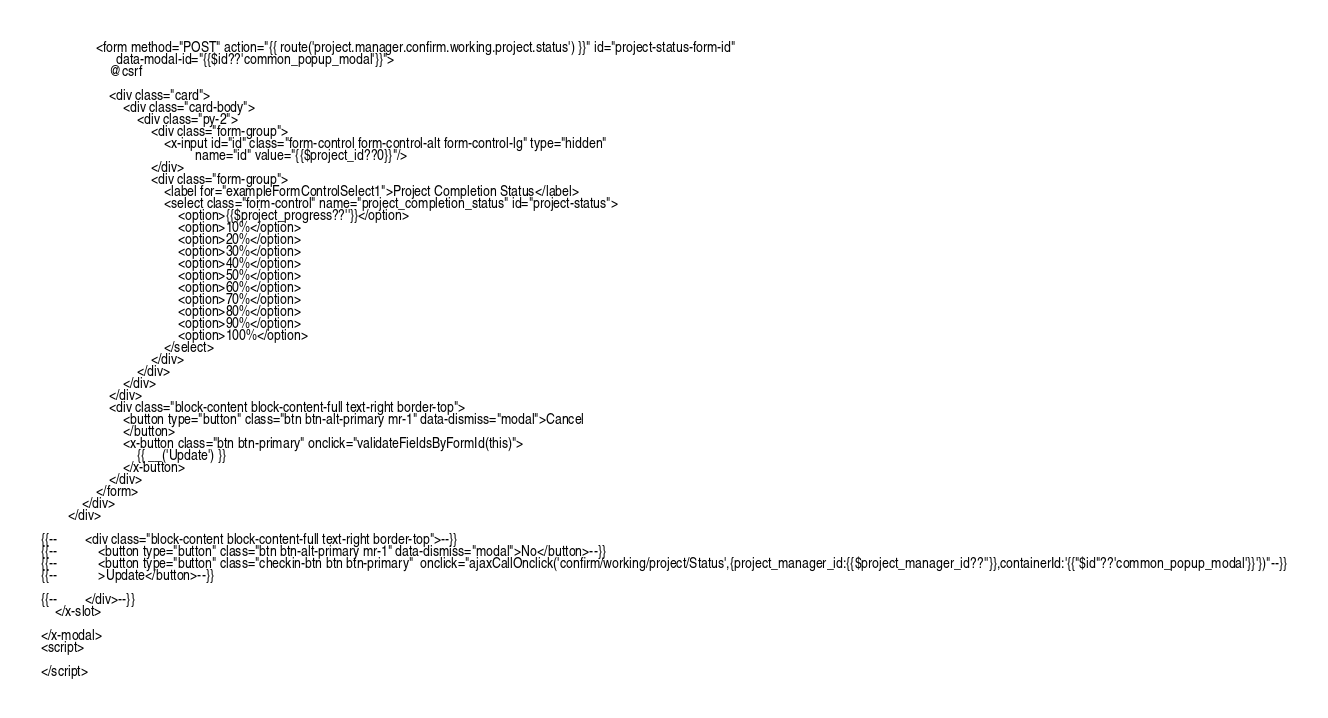Convert code to text. <code><loc_0><loc_0><loc_500><loc_500><_PHP_>                <form method="POST" action="{{ route('project.manager.confirm.working.project.status') }}" id="project-status-form-id"
                      data-modal-id="{{$id??'common_popup_modal'}}">
                    @csrf

                    <div class="card">
                        <div class="card-body">
                            <div class="py-2">
                                <div class="form-group">
                                    <x-input id="id" class="form-control form-control-alt form-control-lg" type="hidden"
                                             name="id" value="{{$project_id??0}}"/>
                                </div>
                                <div class="form-group">
                                    <label for="exampleFormControlSelect1">Project Completion Status</label>
                                    <select class="form-control" name="project_completion_status" id="project-status">
                                        <option>{{$project_progress??''}}</option>
                                        <option>10%</option>
                                        <option>20%</option>
                                        <option>30%</option>
                                        <option>40%</option>
                                        <option>50%</option>
                                        <option>60%</option>
                                        <option>70%</option>
                                        <option>80%</option>
                                        <option>90%</option>
                                        <option>100%</option>
                                    </select>
                                </div>
                            </div>
                        </div>
                    </div>
                    <div class="block-content block-content-full text-right border-top">
                        <button type="button" class="btn btn-alt-primary mr-1" data-dismiss="modal">Cancel
                        </button>
                        <x-button class="btn btn-primary" onclick="validateFieldsByFormId(this)">
                            {{ __('Update') }}
                        </x-button>
                    </div>
                </form>
            </div>
        </div>

{{--        <div class="block-content block-content-full text-right border-top">--}}
{{--            <button type="button" class="btn btn-alt-primary mr-1" data-dismiss="modal">No</button>--}}
{{--            <button type="button" class="checkin-btn btn btn-primary"  onclick="ajaxCallOnclick('confirm/working/project/Status',{project_manager_id:{{$project_manager_id??''}},containerId:'{{"$id"??'common_popup_modal'}}'})"--}}
{{--            >Update</button>--}}

{{--        </div>--}}
    </x-slot>

</x-modal>
<script>

</script>
</code> 